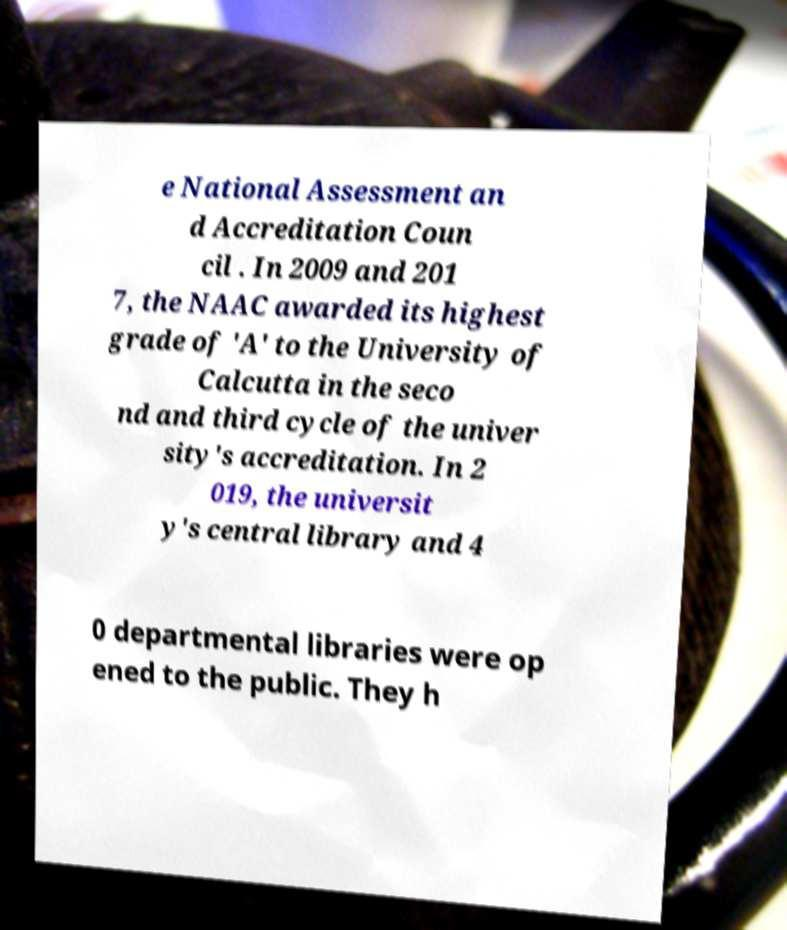Can you accurately transcribe the text from the provided image for me? e National Assessment an d Accreditation Coun cil . In 2009 and 201 7, the NAAC awarded its highest grade of 'A' to the University of Calcutta in the seco nd and third cycle of the univer sity's accreditation. In 2 019, the universit y's central library and 4 0 departmental libraries were op ened to the public. They h 